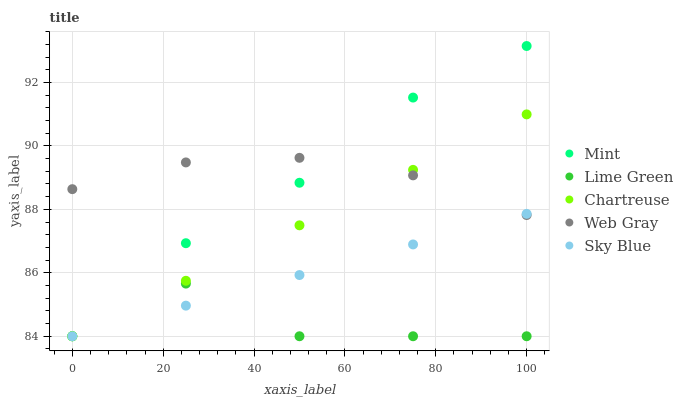Does Lime Green have the minimum area under the curve?
Answer yes or no. Yes. Does Web Gray have the maximum area under the curve?
Answer yes or no. Yes. Does Chartreuse have the minimum area under the curve?
Answer yes or no. No. Does Chartreuse have the maximum area under the curve?
Answer yes or no. No. Is Sky Blue the smoothest?
Answer yes or no. Yes. Is Lime Green the roughest?
Answer yes or no. Yes. Is Chartreuse the smoothest?
Answer yes or no. No. Is Chartreuse the roughest?
Answer yes or no. No. Does Lime Green have the lowest value?
Answer yes or no. Yes. Does Web Gray have the lowest value?
Answer yes or no. No. Does Mint have the highest value?
Answer yes or no. Yes. Does Chartreuse have the highest value?
Answer yes or no. No. Is Lime Green less than Web Gray?
Answer yes or no. Yes. Is Web Gray greater than Lime Green?
Answer yes or no. Yes. Does Sky Blue intersect Chartreuse?
Answer yes or no. Yes. Is Sky Blue less than Chartreuse?
Answer yes or no. No. Is Sky Blue greater than Chartreuse?
Answer yes or no. No. Does Lime Green intersect Web Gray?
Answer yes or no. No. 